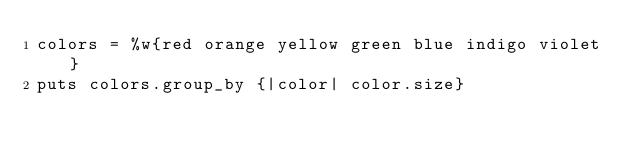Convert code to text. <code><loc_0><loc_0><loc_500><loc_500><_Ruby_>colors = %w{red orange yellow green blue indigo violet}
puts colors.group_by {|color| color.size}
</code> 